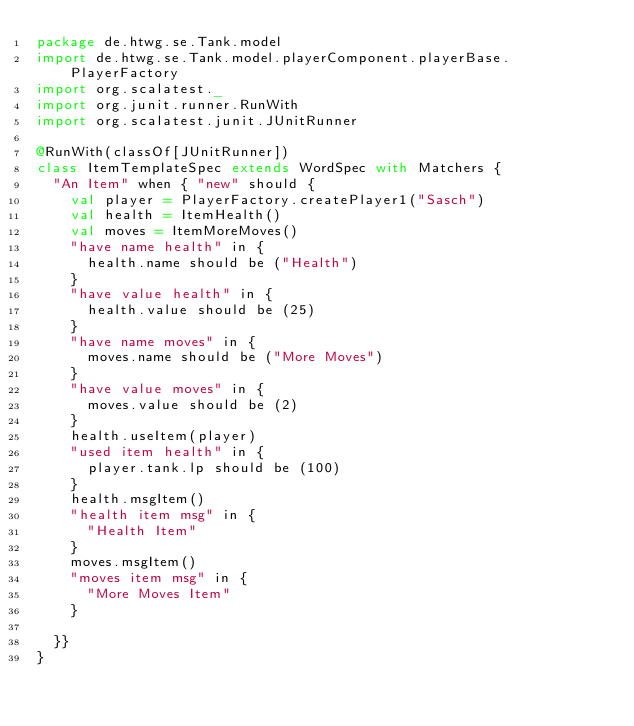<code> <loc_0><loc_0><loc_500><loc_500><_Scala_>package de.htwg.se.Tank.model
import de.htwg.se.Tank.model.playerComponent.playerBase.PlayerFactory
import org.scalatest._
import org.junit.runner.RunWith
import org.scalatest.junit.JUnitRunner

@RunWith(classOf[JUnitRunner])
class ItemTemplateSpec extends WordSpec with Matchers {
  "An Item" when { "new" should {
    val player = PlayerFactory.createPlayer1("Sasch")
    val health = ItemHealth()
    val moves = ItemMoreMoves()
    "have name health" in {
      health.name should be ("Health")
    }
    "have value health" in {
      health.value should be (25)
    }
    "have name moves" in {
      moves.name should be ("More Moves")
    }
    "have value moves" in {
      moves.value should be (2)
    }
    health.useItem(player)
    "used item health" in {
      player.tank.lp should be (100)
    }
    health.msgItem()
    "health item msg" in {
      "Health Item"
    }
    moves.msgItem()
    "moves item msg" in {
      "More Moves Item"
    }

  }}
}
</code> 